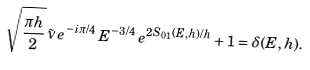<formula> <loc_0><loc_0><loc_500><loc_500>\sqrt { \frac { \pi h } 2 } \, \tilde { \nu } \, e ^ { - i \pi / 4 } \, E ^ { - 3 / 4 } \, e ^ { 2 S _ { 0 1 } ( E , h ) / h } + 1 = \delta ( E , h ) .</formula> 